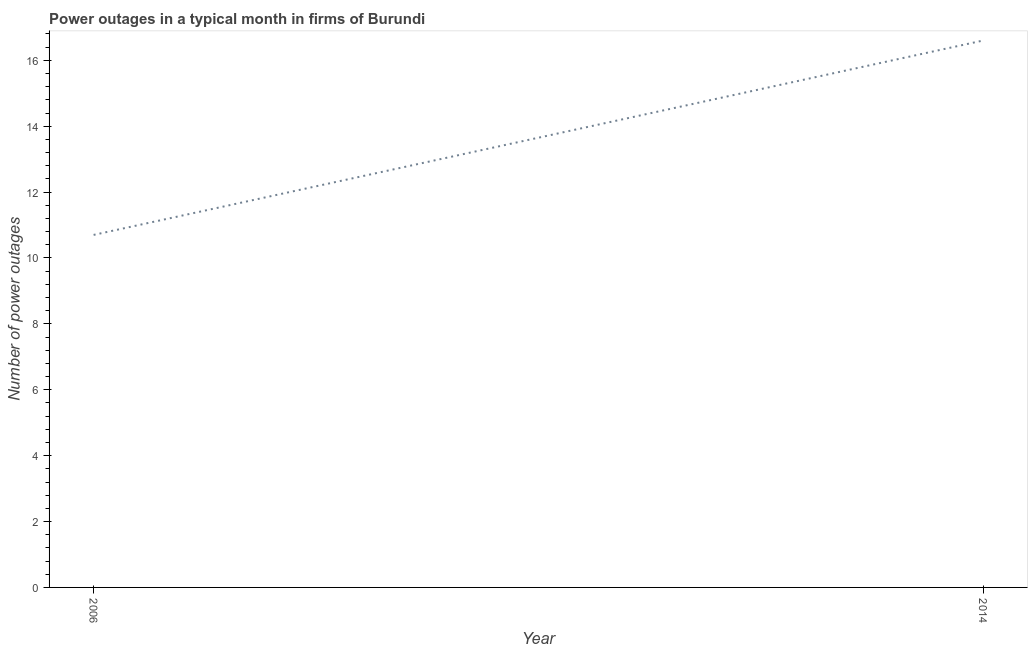What is the number of power outages in 2006?
Offer a terse response. 10.7. Across all years, what is the maximum number of power outages?
Your answer should be compact. 16.6. Across all years, what is the minimum number of power outages?
Ensure brevity in your answer.  10.7. In which year was the number of power outages minimum?
Your answer should be compact. 2006. What is the sum of the number of power outages?
Your response must be concise. 27.3. What is the difference between the number of power outages in 2006 and 2014?
Provide a short and direct response. -5.9. What is the average number of power outages per year?
Your response must be concise. 13.65. What is the median number of power outages?
Give a very brief answer. 13.65. Do a majority of the years between 2006 and 2014 (inclusive) have number of power outages greater than 10.8 ?
Ensure brevity in your answer.  No. What is the ratio of the number of power outages in 2006 to that in 2014?
Make the answer very short. 0.64. In how many years, is the number of power outages greater than the average number of power outages taken over all years?
Provide a short and direct response. 1. Does the number of power outages monotonically increase over the years?
Offer a terse response. Yes. How many lines are there?
Give a very brief answer. 1. How many years are there in the graph?
Keep it short and to the point. 2. Does the graph contain any zero values?
Give a very brief answer. No. What is the title of the graph?
Your response must be concise. Power outages in a typical month in firms of Burundi. What is the label or title of the X-axis?
Give a very brief answer. Year. What is the label or title of the Y-axis?
Provide a succinct answer. Number of power outages. What is the Number of power outages in 2006?
Provide a succinct answer. 10.7. What is the difference between the Number of power outages in 2006 and 2014?
Offer a very short reply. -5.9. What is the ratio of the Number of power outages in 2006 to that in 2014?
Ensure brevity in your answer.  0.65. 